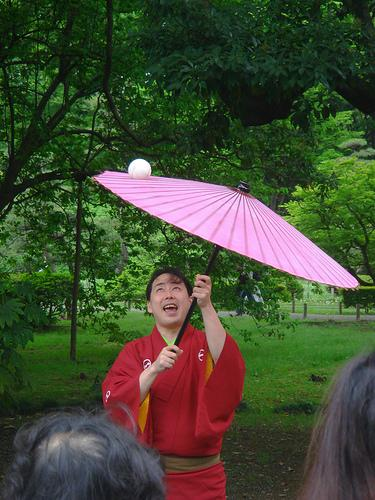Why is the ball on the parasol?

Choices:
A) is random
B) landed there
C) is trick
D) fell there is trick 